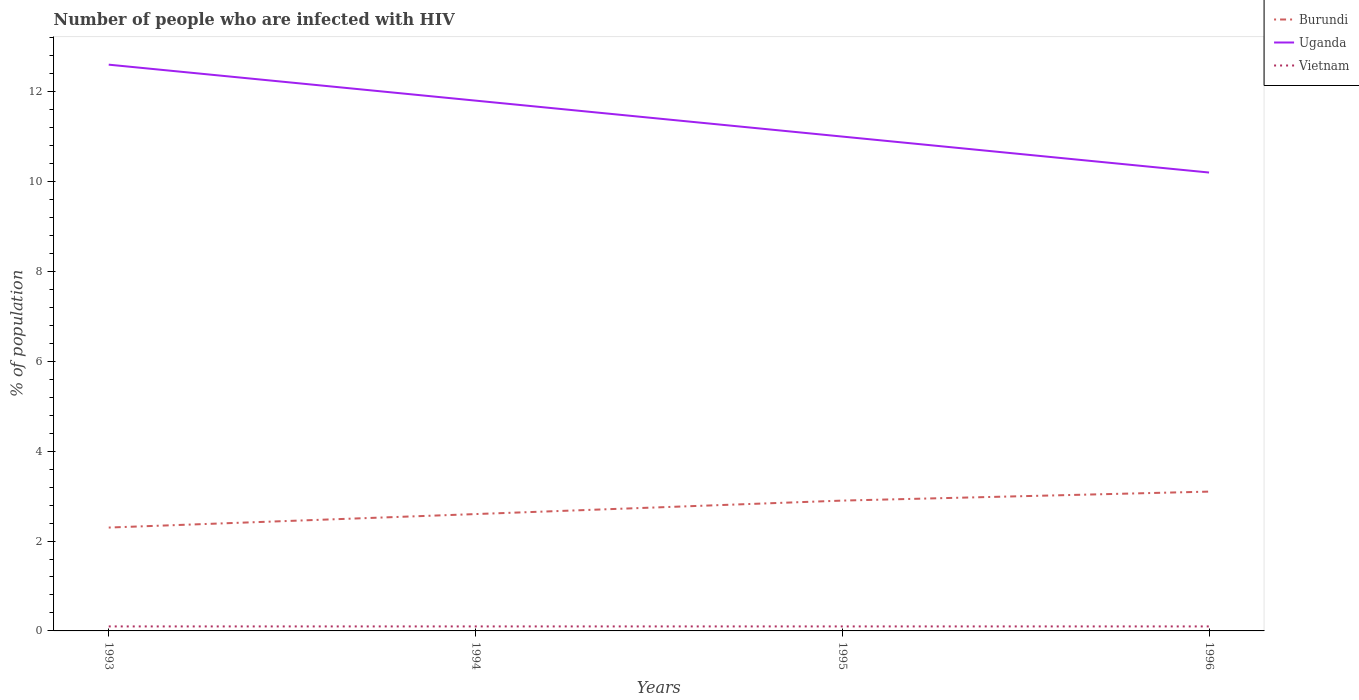How many different coloured lines are there?
Provide a succinct answer. 3. Is the number of lines equal to the number of legend labels?
Ensure brevity in your answer.  Yes. Across all years, what is the maximum percentage of HIV infected population in in Vietnam?
Give a very brief answer. 0.1. In which year was the percentage of HIV infected population in in Uganda maximum?
Your answer should be compact. 1996. What is the total percentage of HIV infected population in in Burundi in the graph?
Your response must be concise. -0.2. What is the difference between the highest and the second highest percentage of HIV infected population in in Uganda?
Offer a very short reply. 2.4. What is the difference between the highest and the lowest percentage of HIV infected population in in Vietnam?
Provide a short and direct response. 0. How many years are there in the graph?
Your response must be concise. 4. Are the values on the major ticks of Y-axis written in scientific E-notation?
Your answer should be compact. No. What is the title of the graph?
Give a very brief answer. Number of people who are infected with HIV. Does "Macao" appear as one of the legend labels in the graph?
Provide a short and direct response. No. What is the label or title of the X-axis?
Your response must be concise. Years. What is the label or title of the Y-axis?
Your answer should be very brief. % of population. What is the % of population in Uganda in 1993?
Your answer should be compact. 12.6. What is the % of population of Vietnam in 1993?
Your response must be concise. 0.1. What is the % of population of Uganda in 1994?
Your answer should be very brief. 11.8. What is the % of population in Vietnam in 1994?
Your answer should be very brief. 0.1. What is the % of population in Burundi in 1995?
Make the answer very short. 2.9. Across all years, what is the maximum % of population in Burundi?
Make the answer very short. 3.1. Across all years, what is the minimum % of population of Burundi?
Make the answer very short. 2.3. Across all years, what is the minimum % of population in Uganda?
Ensure brevity in your answer.  10.2. Across all years, what is the minimum % of population in Vietnam?
Give a very brief answer. 0.1. What is the total % of population of Burundi in the graph?
Give a very brief answer. 10.9. What is the total % of population of Uganda in the graph?
Keep it short and to the point. 45.6. What is the total % of population in Vietnam in the graph?
Offer a terse response. 0.4. What is the difference between the % of population of Uganda in 1993 and that in 1994?
Offer a terse response. 0.8. What is the difference between the % of population in Vietnam in 1993 and that in 1994?
Keep it short and to the point. 0. What is the difference between the % of population of Vietnam in 1993 and that in 1995?
Provide a short and direct response. 0. What is the difference between the % of population of Uganda in 1993 and that in 1996?
Give a very brief answer. 2.4. What is the difference between the % of population of Uganda in 1994 and that in 1995?
Your answer should be compact. 0.8. What is the difference between the % of population of Vietnam in 1994 and that in 1996?
Give a very brief answer. 0. What is the difference between the % of population of Uganda in 1995 and that in 1996?
Offer a very short reply. 0.8. What is the difference between the % of population in Vietnam in 1995 and that in 1996?
Provide a short and direct response. 0. What is the difference between the % of population in Uganda in 1993 and the % of population in Vietnam in 1994?
Your answer should be compact. 12.5. What is the difference between the % of population of Burundi in 1993 and the % of population of Vietnam in 1995?
Provide a short and direct response. 2.2. What is the difference between the % of population in Uganda in 1993 and the % of population in Vietnam in 1995?
Give a very brief answer. 12.5. What is the difference between the % of population of Burundi in 1993 and the % of population of Uganda in 1996?
Offer a terse response. -7.9. What is the difference between the % of population of Burundi in 1993 and the % of population of Vietnam in 1996?
Provide a short and direct response. 2.2. What is the difference between the % of population of Burundi in 1994 and the % of population of Uganda in 1995?
Provide a succinct answer. -8.4. What is the difference between the % of population in Uganda in 1994 and the % of population in Vietnam in 1995?
Give a very brief answer. 11.7. What is the difference between the % of population in Burundi in 1994 and the % of population in Uganda in 1996?
Provide a succinct answer. -7.6. What is the difference between the % of population in Uganda in 1994 and the % of population in Vietnam in 1996?
Ensure brevity in your answer.  11.7. What is the difference between the % of population in Burundi in 1995 and the % of population in Uganda in 1996?
Provide a short and direct response. -7.3. What is the difference between the % of population in Burundi in 1995 and the % of population in Vietnam in 1996?
Provide a short and direct response. 2.8. What is the difference between the % of population in Uganda in 1995 and the % of population in Vietnam in 1996?
Offer a very short reply. 10.9. What is the average % of population in Burundi per year?
Your response must be concise. 2.73. In the year 1993, what is the difference between the % of population of Burundi and % of population of Uganda?
Your answer should be compact. -10.3. In the year 1994, what is the difference between the % of population of Burundi and % of population of Vietnam?
Ensure brevity in your answer.  2.5. In the year 1994, what is the difference between the % of population in Uganda and % of population in Vietnam?
Ensure brevity in your answer.  11.7. In the year 1995, what is the difference between the % of population in Burundi and % of population in Uganda?
Your answer should be very brief. -8.1. In the year 1996, what is the difference between the % of population of Burundi and % of population of Vietnam?
Give a very brief answer. 3. In the year 1996, what is the difference between the % of population of Uganda and % of population of Vietnam?
Keep it short and to the point. 10.1. What is the ratio of the % of population of Burundi in 1993 to that in 1994?
Your answer should be compact. 0.88. What is the ratio of the % of population in Uganda in 1993 to that in 1994?
Your response must be concise. 1.07. What is the ratio of the % of population of Vietnam in 1993 to that in 1994?
Make the answer very short. 1. What is the ratio of the % of population in Burundi in 1993 to that in 1995?
Keep it short and to the point. 0.79. What is the ratio of the % of population in Uganda in 1993 to that in 1995?
Give a very brief answer. 1.15. What is the ratio of the % of population of Vietnam in 1993 to that in 1995?
Your response must be concise. 1. What is the ratio of the % of population in Burundi in 1993 to that in 1996?
Give a very brief answer. 0.74. What is the ratio of the % of population in Uganda in 1993 to that in 1996?
Keep it short and to the point. 1.24. What is the ratio of the % of population in Vietnam in 1993 to that in 1996?
Keep it short and to the point. 1. What is the ratio of the % of population in Burundi in 1994 to that in 1995?
Your answer should be compact. 0.9. What is the ratio of the % of population of Uganda in 1994 to that in 1995?
Your response must be concise. 1.07. What is the ratio of the % of population in Burundi in 1994 to that in 1996?
Your answer should be compact. 0.84. What is the ratio of the % of population of Uganda in 1994 to that in 1996?
Make the answer very short. 1.16. What is the ratio of the % of population of Vietnam in 1994 to that in 1996?
Offer a very short reply. 1. What is the ratio of the % of population of Burundi in 1995 to that in 1996?
Offer a terse response. 0.94. What is the ratio of the % of population in Uganda in 1995 to that in 1996?
Keep it short and to the point. 1.08. What is the difference between the highest and the second highest % of population in Burundi?
Offer a terse response. 0.2. What is the difference between the highest and the second highest % of population in Uganda?
Your response must be concise. 0.8. What is the difference between the highest and the second highest % of population in Vietnam?
Make the answer very short. 0. What is the difference between the highest and the lowest % of population of Vietnam?
Provide a short and direct response. 0. 